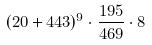<formula> <loc_0><loc_0><loc_500><loc_500>( 2 0 + 4 4 3 ) ^ { 9 } \cdot \frac { 1 9 5 } { 4 6 9 } \cdot 8</formula> 